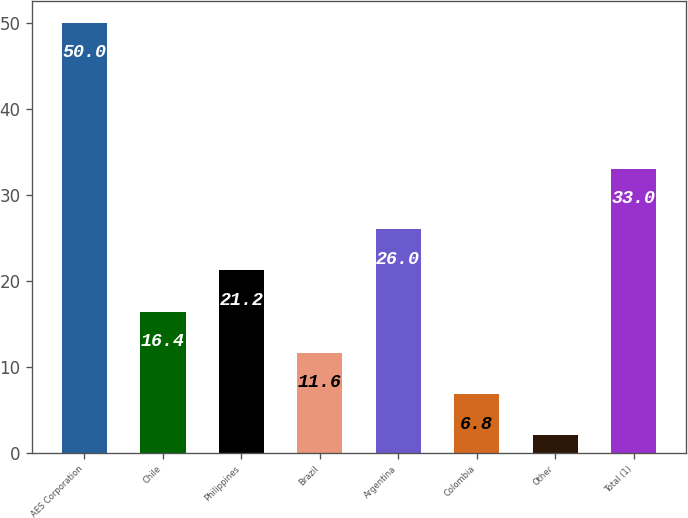<chart> <loc_0><loc_0><loc_500><loc_500><bar_chart><fcel>AES Corporation<fcel>Chile<fcel>Philippines<fcel>Brazil<fcel>Argentina<fcel>Colombia<fcel>Other<fcel>Total (1)<nl><fcel>50<fcel>16.4<fcel>21.2<fcel>11.6<fcel>26<fcel>6.8<fcel>2<fcel>33<nl></chart> 